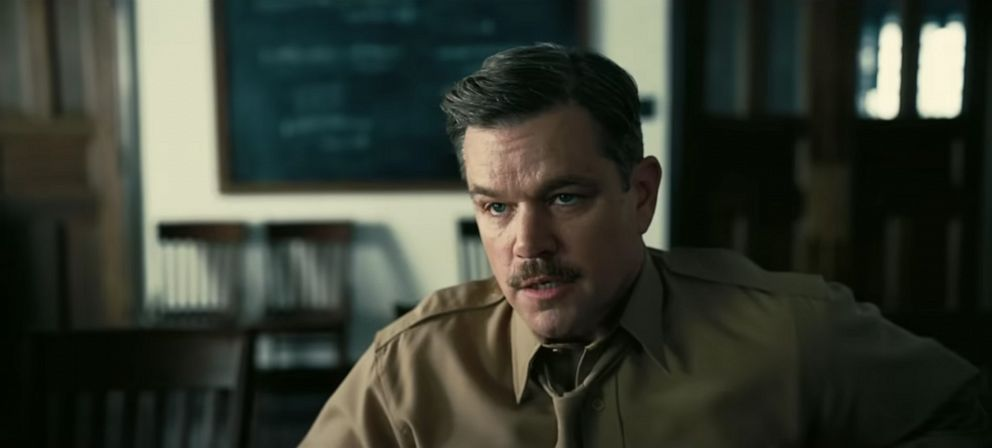What's happening in the scene? In the image, a man, dressed in a beige shirt, is sitting on a wooden chair in what appears to be a room with a blackboard covered in chalk-written equations. His face, adorned with a mustache, reflects a serious and thoughtful demeanor as he stares to his left, suggesting he is deeply engaged in a conversation or contemplation. The setting has an academic vibe, implying the scene might be taking place in an educational institution. 